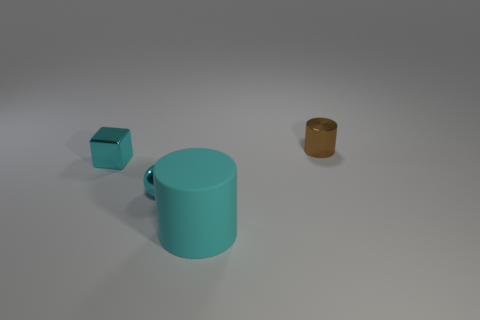Is the color of the small ball the same as the cube?
Make the answer very short. Yes. How many metal objects are cyan blocks or big yellow objects?
Make the answer very short. 1. Are there any cyan balls behind the cylinder that is in front of the tiny shiny thing right of the cyan metallic sphere?
Give a very brief answer. Yes. What size is the sphere that is the same material as the tiny cylinder?
Make the answer very short. Small. Are there any small cylinders behind the large thing?
Make the answer very short. Yes. There is a cylinder that is behind the metallic cube; is there a tiny cyan object in front of it?
Give a very brief answer. Yes. Is the size of the cyan shiny thing that is in front of the shiny block the same as the matte thing that is to the right of the cyan shiny sphere?
Provide a short and direct response. No. How many big things are either metallic cubes or yellow matte cylinders?
Make the answer very short. 0. What is the material of the cylinder that is in front of the tiny cyan metallic object that is to the left of the tiny metallic sphere?
Your answer should be very brief. Rubber. There is a large matte thing that is the same color as the small shiny ball; what is its shape?
Give a very brief answer. Cylinder. 